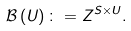<formula> <loc_0><loc_0><loc_500><loc_500>\mathcal { B } \left ( U \right ) \colon = Z ^ { S \times U } .</formula> 